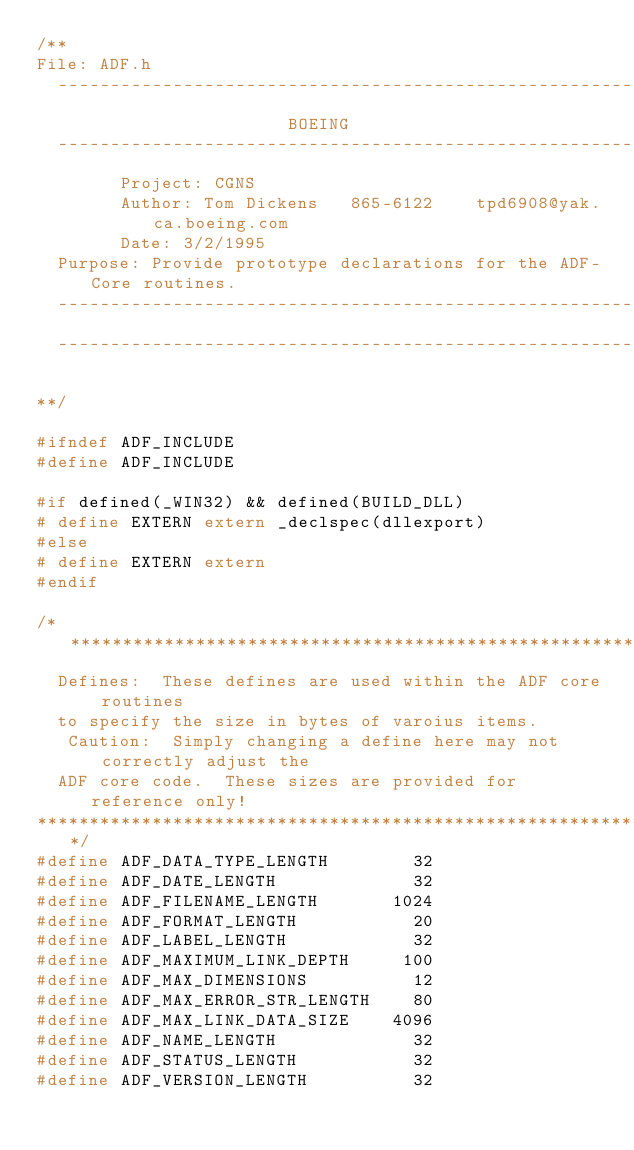<code> <loc_0><loc_0><loc_500><loc_500><_C_>/**
File:	ADF.h
  ----------------------------------------------------------------------
                        BOEING
  ----------------------------------------------------------------------
        Project: CGNS
        Author: Tom Dickens   865-6122    tpd6908@yak.ca.boeing.com
        Date: 3/2/1995
	Purpose: Provide prototype declarations for the ADF-Core routines.
  ----------------------------------------------------------------------
  ----------------------------------------------------------------------

**/

#ifndef ADF_INCLUDE
#define ADF_INCLUDE

#if defined(_WIN32) && defined(BUILD_DLL)
# define EXTERN extern _declspec(dllexport)
#else
# define EXTERN extern
#endif

/***********************************************************************
	Defines:  These defines are used within the ADF core routines
	to specify the size in bytes of varoius items.
   Caution:  Simply changing a define here may not correctly adjust the
	ADF core code.  These sizes are provided for reference only!
***********************************************************************/
#define ADF_DATA_TYPE_LENGTH        32
#define ADF_DATE_LENGTH             32
#define ADF_FILENAME_LENGTH       1024
#define ADF_FORMAT_LENGTH           20
#define ADF_LABEL_LENGTH            32
#define ADF_MAXIMUM_LINK_DEPTH     100
#define ADF_MAX_DIMENSIONS          12
#define ADF_MAX_ERROR_STR_LENGTH    80
#define ADF_MAX_LINK_DATA_SIZE    4096
#define ADF_NAME_LENGTH             32
#define ADF_STATUS_LENGTH           32
#define ADF_VERSION_LENGTH          32
</code> 